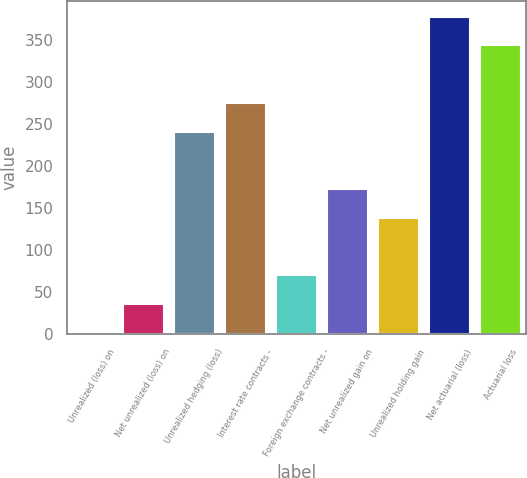<chart> <loc_0><loc_0><loc_500><loc_500><bar_chart><fcel>Unrealized (loss) on<fcel>Net unrealized (loss) on<fcel>Unrealized hedging (loss)<fcel>Interest rate contracts -<fcel>Foreign exchange contracts -<fcel>Net unrealized gain on<fcel>Unrealized holding gain<fcel>Net actuarial (loss)<fcel>Actuarial loss<nl><fcel>2<fcel>36.1<fcel>240.7<fcel>274.8<fcel>70.2<fcel>172.5<fcel>138.4<fcel>377.1<fcel>343<nl></chart> 